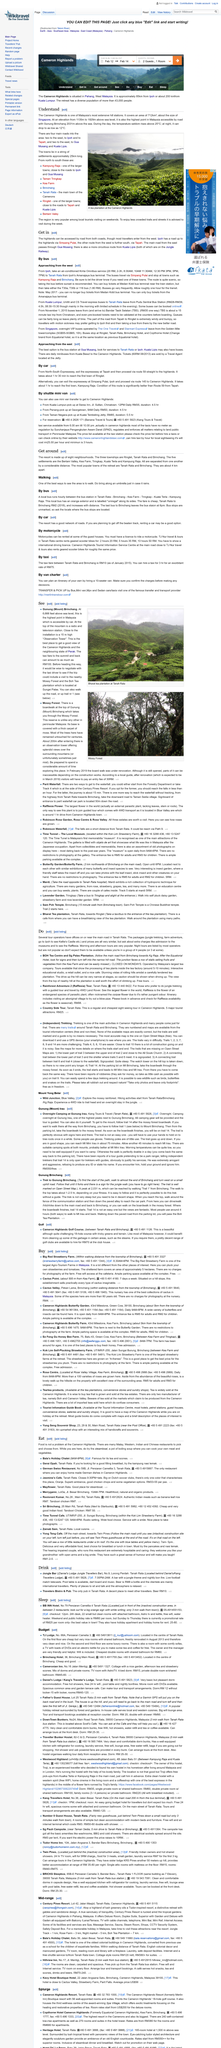Mention a couple of crucial points in this snapshot. At night, the temperature in Cameron Highlands can reach as low as 12 degrees Celsius, making it one of the coldest places in Malaysia. Night tours are available in Tanah Rata for groups of 4 people (or 3 for some tour operators). The Boh Tea Centre and Sg Palas Plantation are not open on Mondays. Cameron Highlands, a hill station in the state of Pahang, covers an area of 712 km2. Tanah Rata offers a variety of tours, including visits to the BOH Tea Centre and Sg Palas Plantation, an exciting Rainforest Adventure, and a scenic Country Side Tour. 